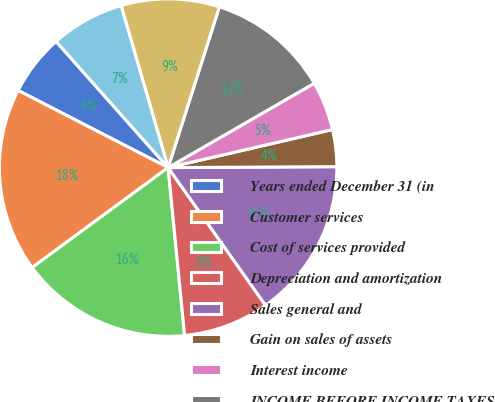<chart> <loc_0><loc_0><loc_500><loc_500><pie_chart><fcel>Years ended December 31 (in<fcel>Customer services<fcel>Cost of services provided<fcel>Depreciation and amortization<fcel>Sales general and<fcel>Gain on sales of assets<fcel>Interest income<fcel>INCOME BEFORE INCOME TAXES<fcel>Current<fcel>Deferred<nl><fcel>5.88%<fcel>17.65%<fcel>16.47%<fcel>8.24%<fcel>15.29%<fcel>3.53%<fcel>4.71%<fcel>11.76%<fcel>9.41%<fcel>7.06%<nl></chart> 